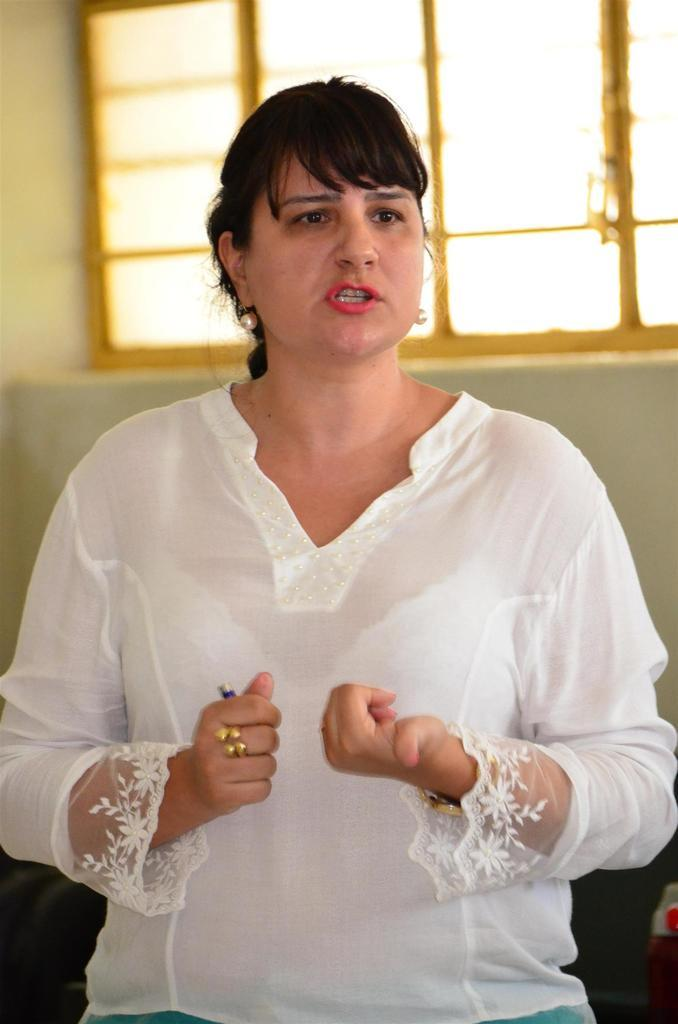Who is the main subject in the foreground of the image? There is a woman in the foreground of the image. What is the woman wearing? The woman is wearing a white dress. What is the woman doing in the image? The woman appears to be talking. What can be seen in the background of the image? There is a wall and a window in the background of the image. What type of lunch is being served in the image? There is no reference to lunch or any food being served in the image. 